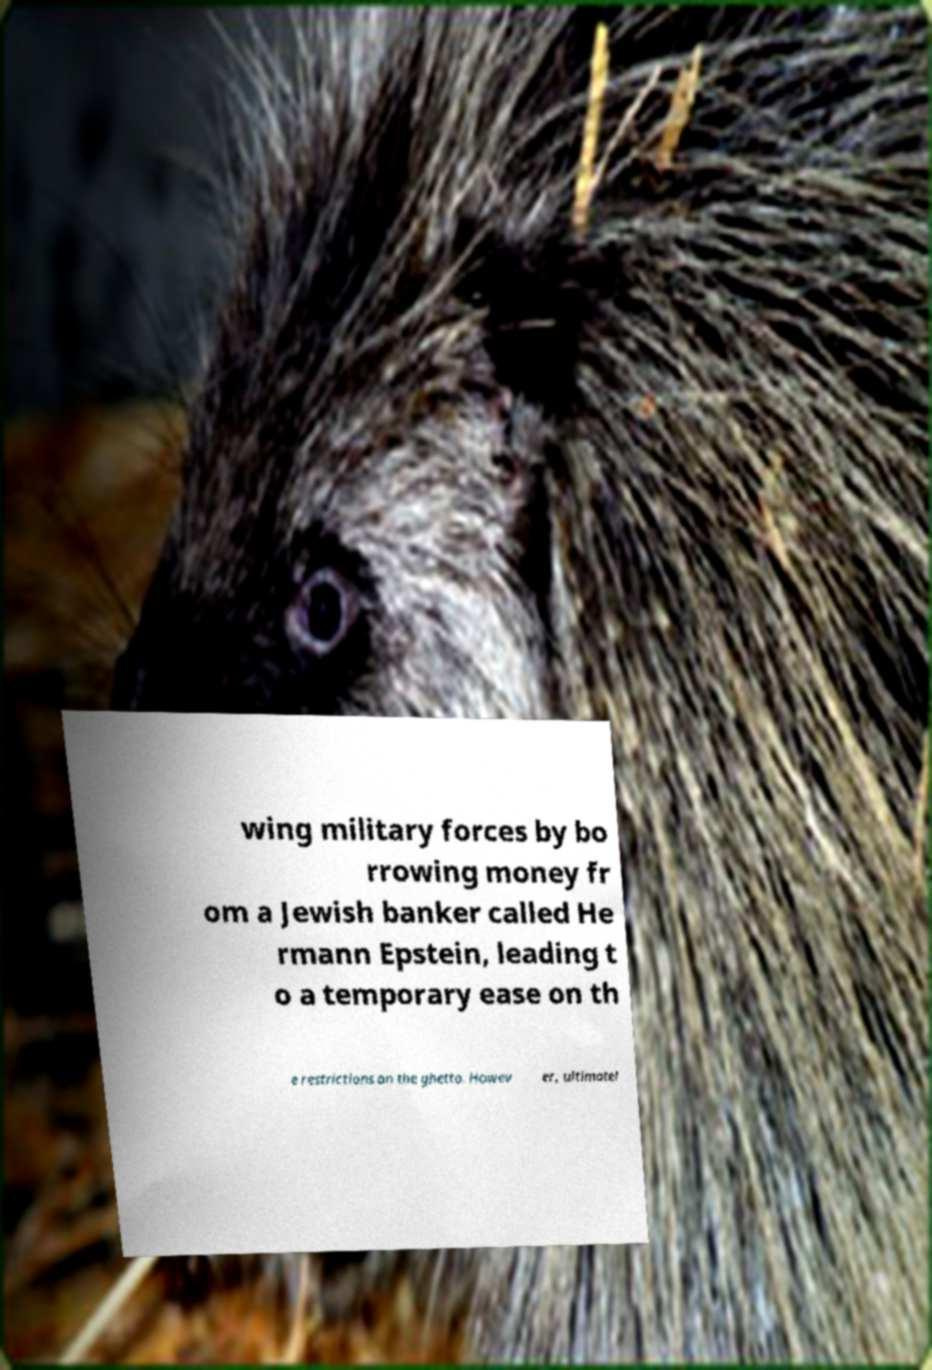Could you assist in decoding the text presented in this image and type it out clearly? wing military forces by bo rrowing money fr om a Jewish banker called He rmann Epstein, leading t o a temporary ease on th e restrictions on the ghetto. Howev er, ultimatel 